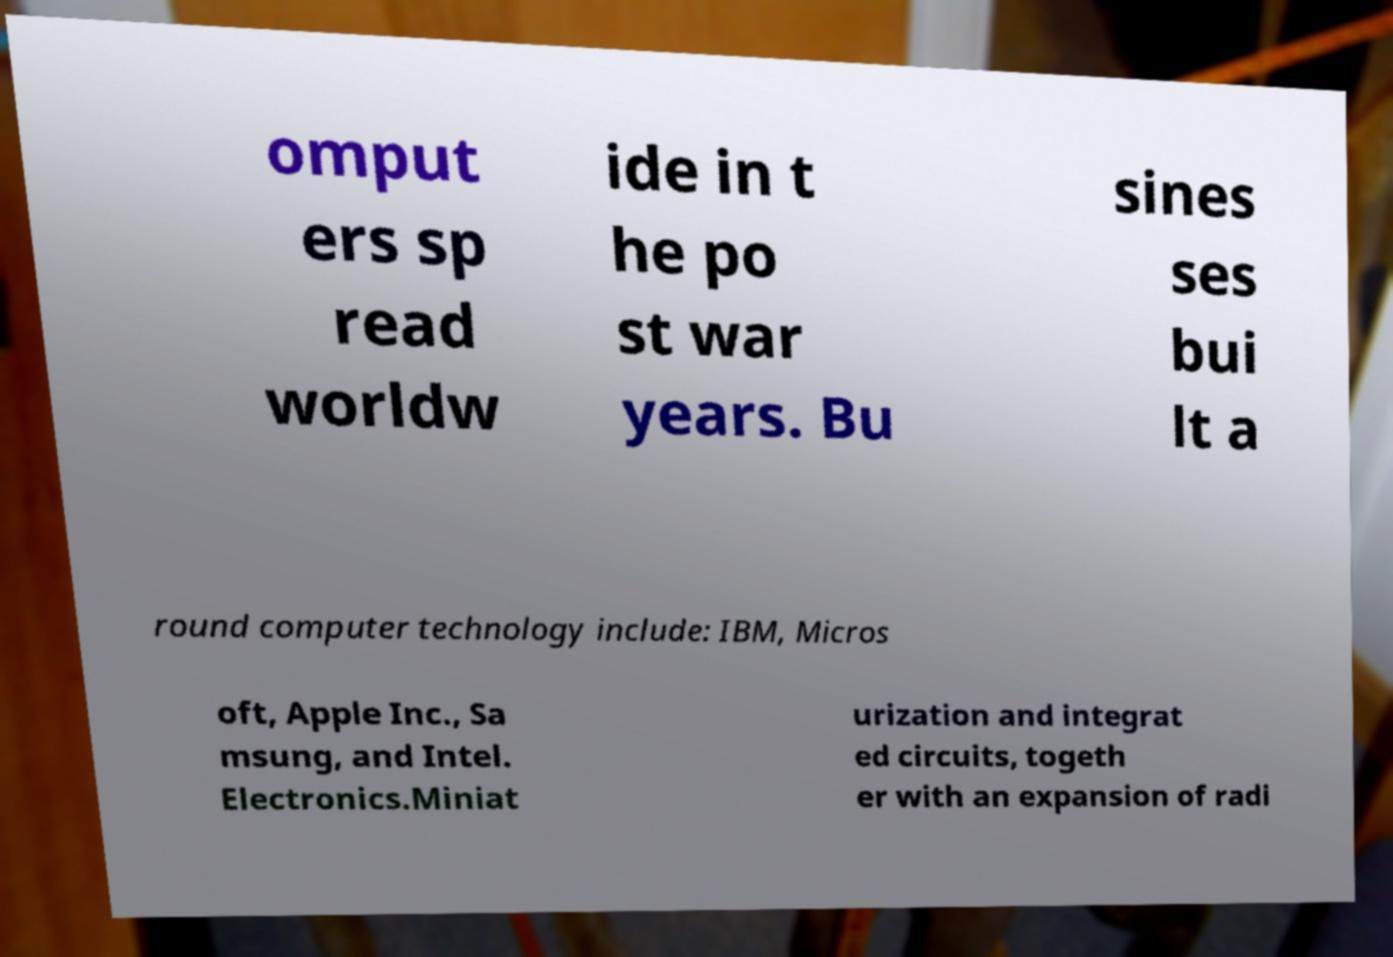Could you extract and type out the text from this image? omput ers sp read worldw ide in t he po st war years. Bu sines ses bui lt a round computer technology include: IBM, Micros oft, Apple Inc., Sa msung, and Intel. Electronics.Miniat urization and integrat ed circuits, togeth er with an expansion of radi 